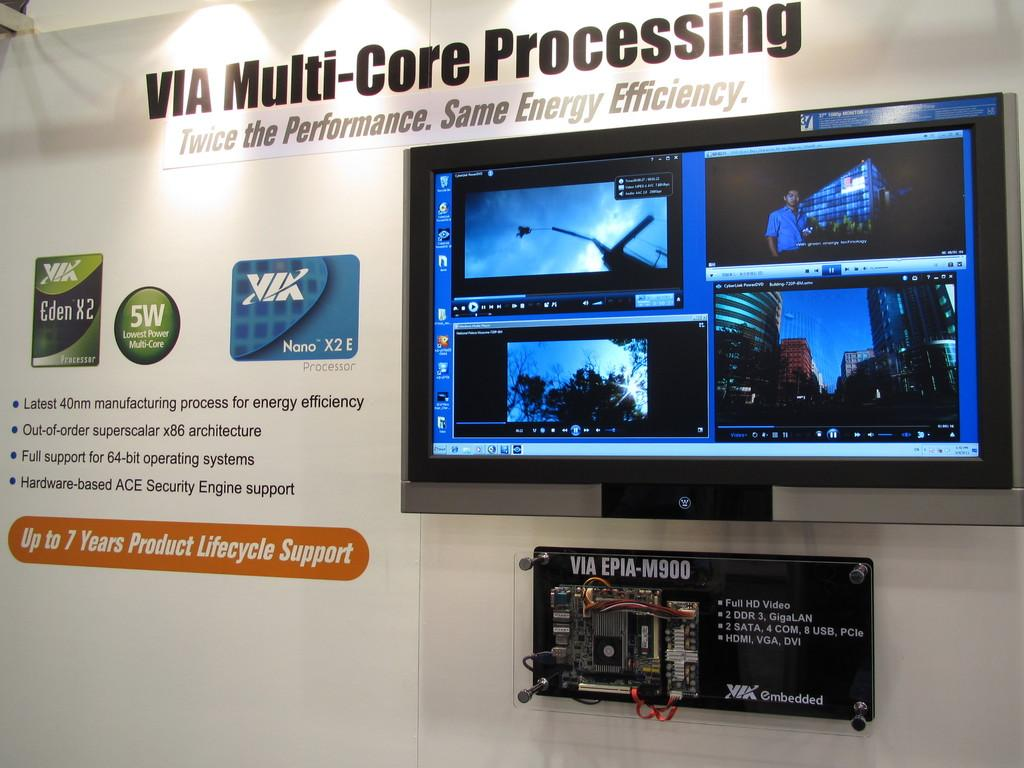<image>
Relay a brief, clear account of the picture shown. A sign for the VIA Multi-Core Processing includes a tv monitor with four displays. 